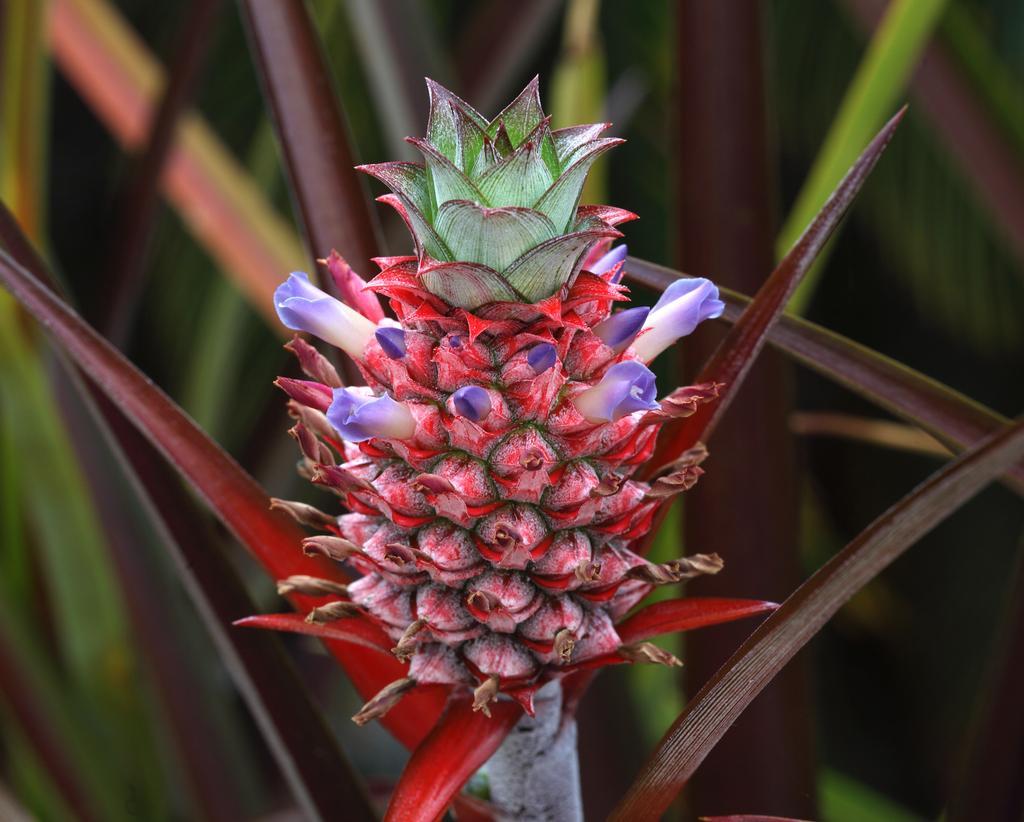Can you describe this image briefly? In this image we can see a bunch of flowers and some leaves. 